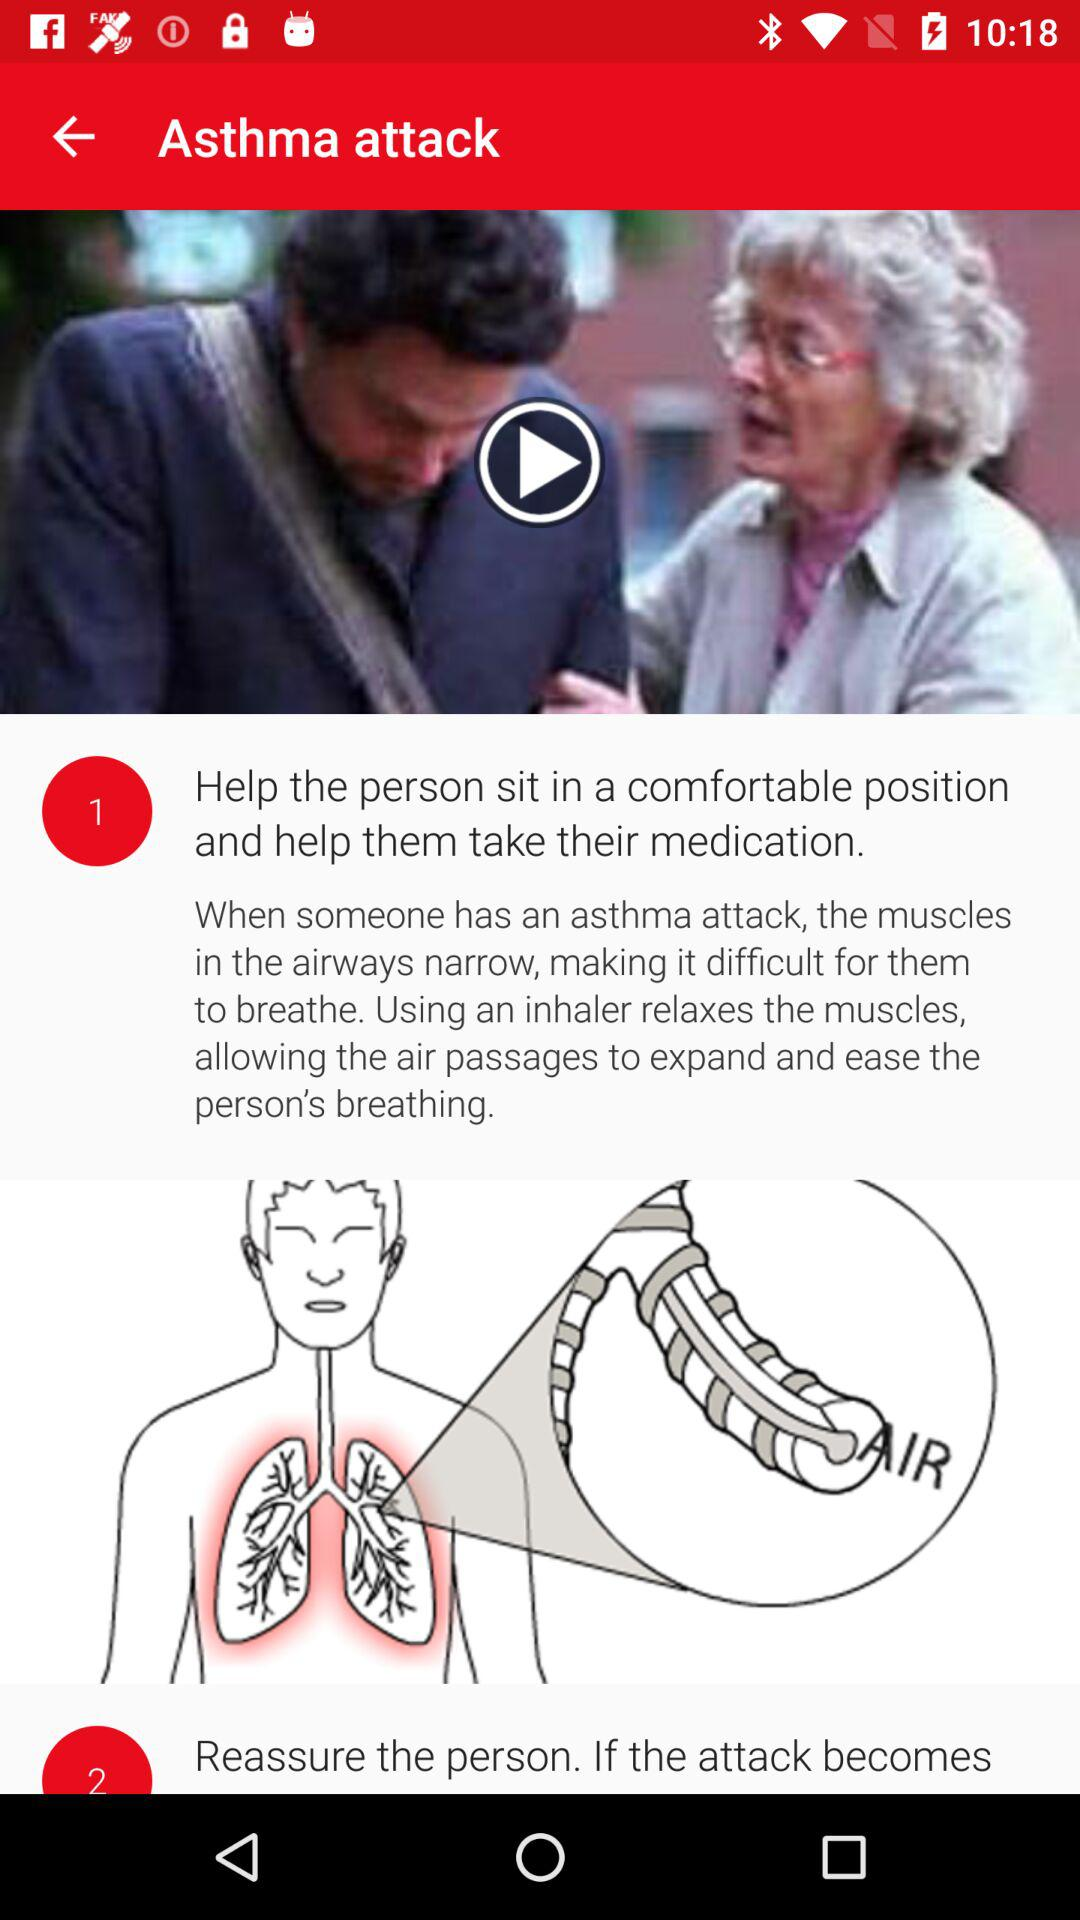How many steps are there in the asthma attack guide?
Answer the question using a single word or phrase. 2 